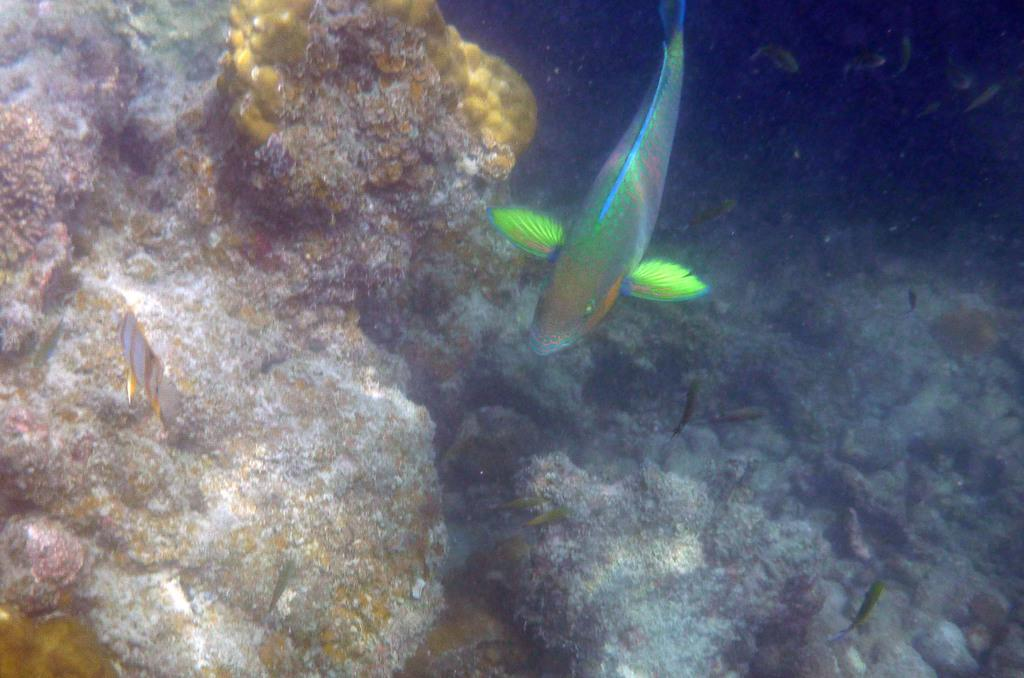What type of animals can be seen in the water in the image? There are fish visible in the water in the image. What other objects or elements can be seen in the water? There are stars visible in the water in the image. Can you see a branch with a rat on it in the image? There is no branch or rat present in the image; it only features fish and stars visible in the water. 